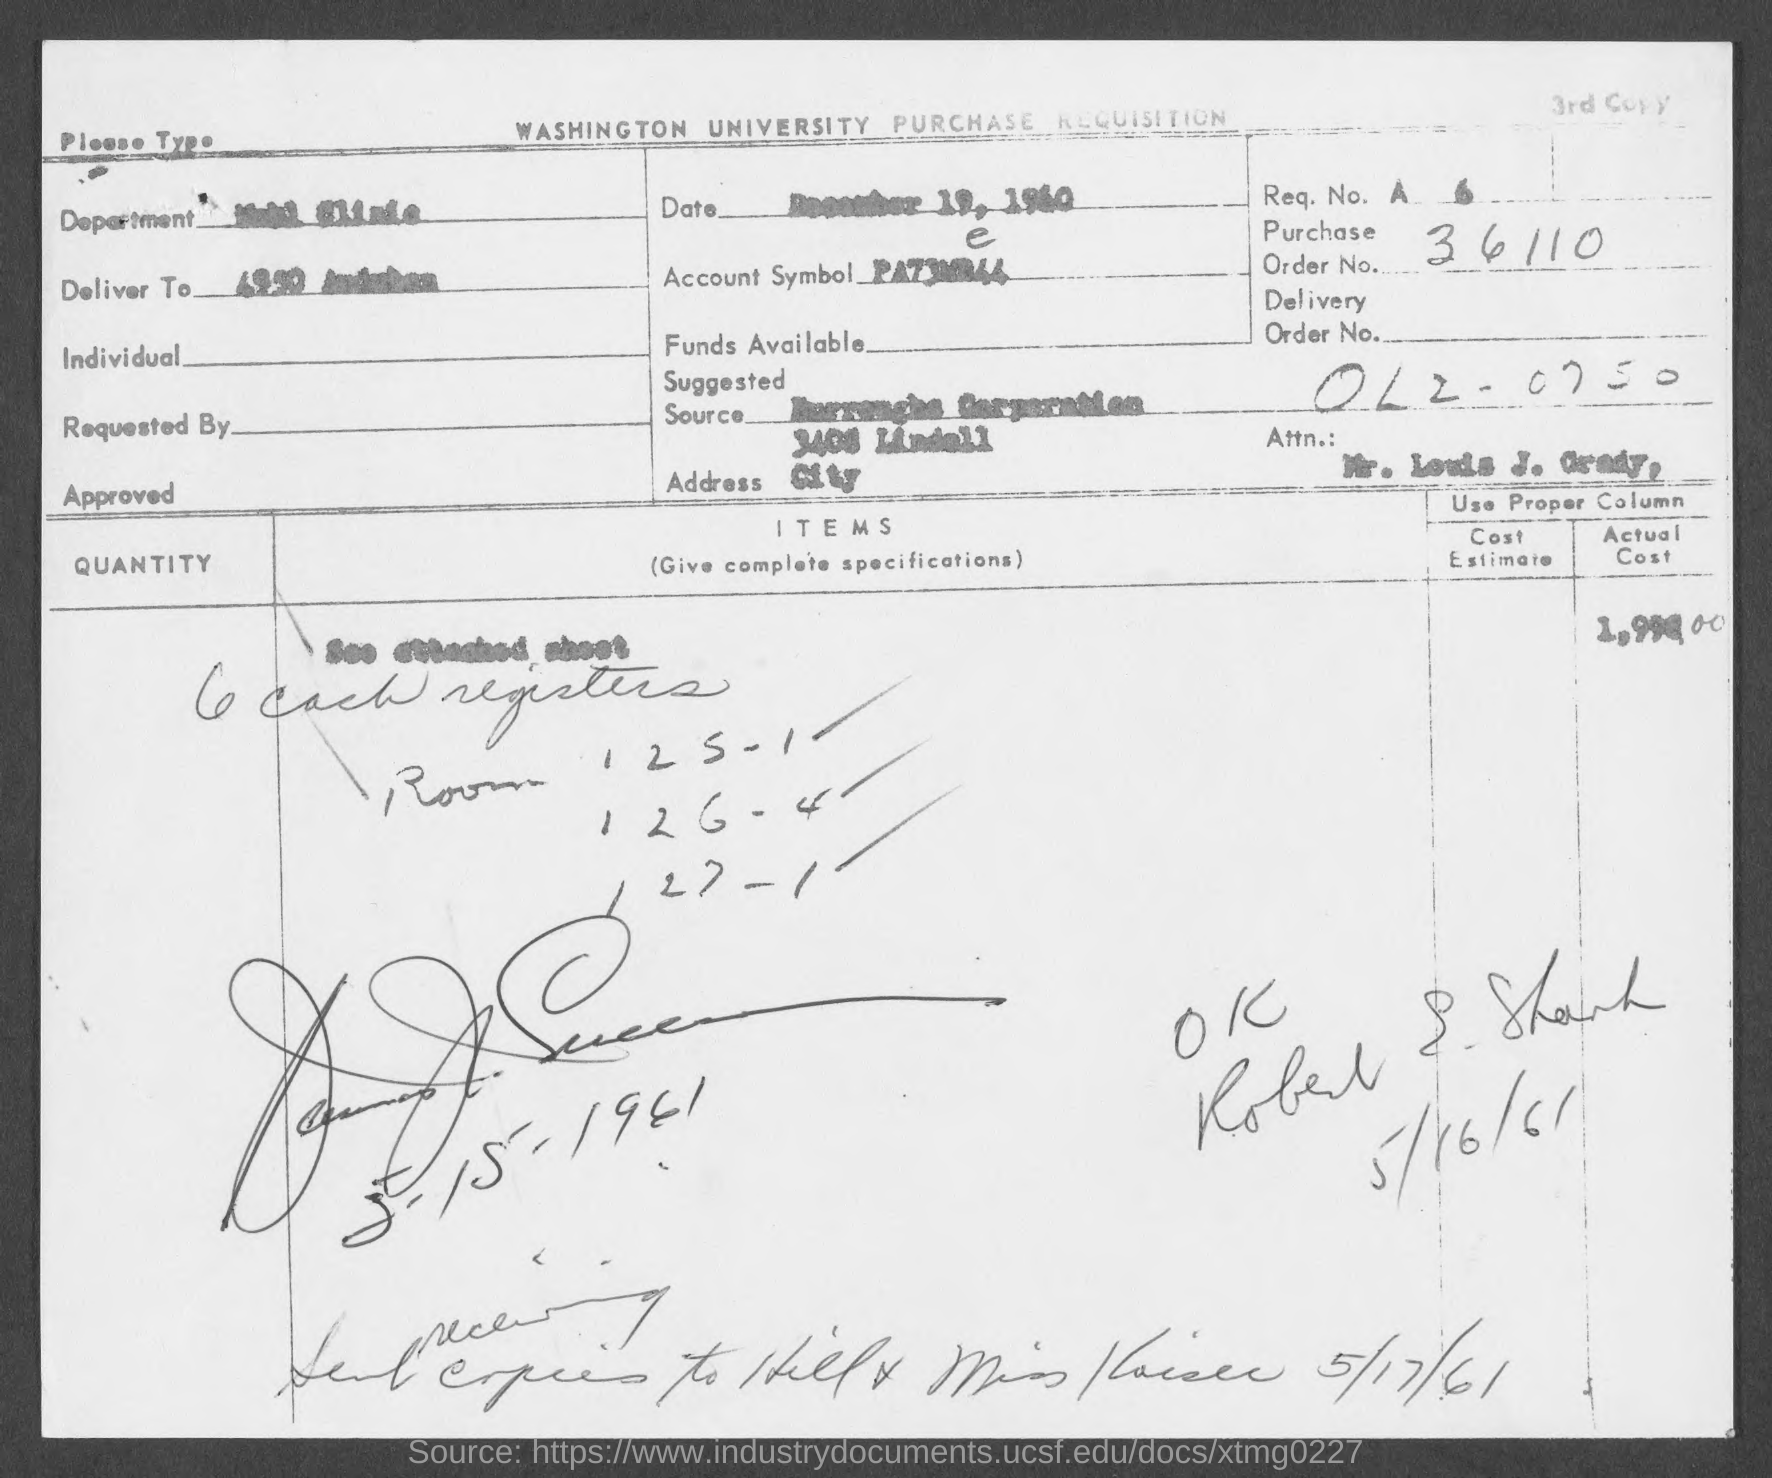Mention a couple of crucial points in this snapshot. The issued date of this document is December 19, 1960. The document provides a request number of 6.. Washington University's Purchase Requisition is provided. The document contains a purchase order number, which is 36110. 